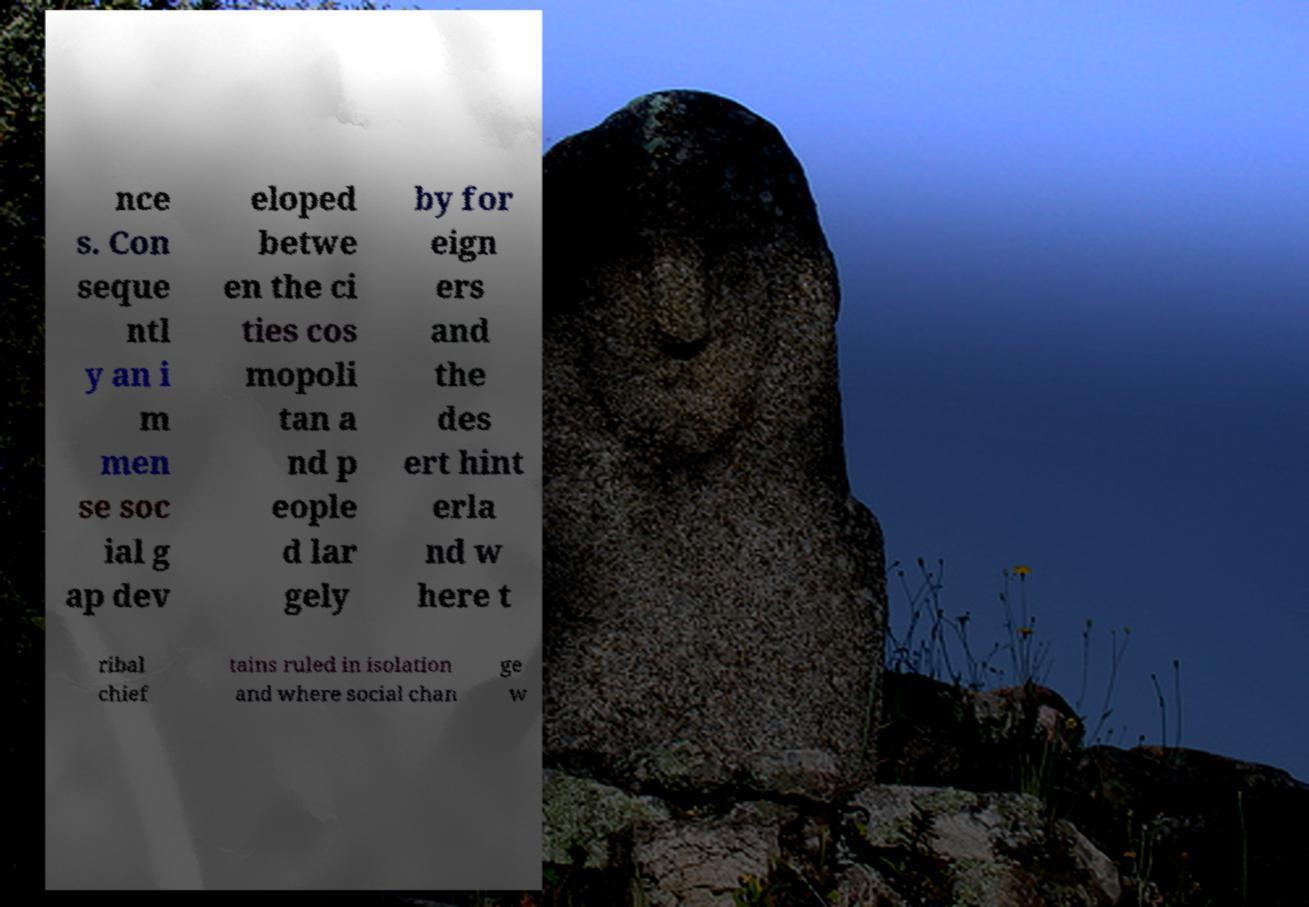I need the written content from this picture converted into text. Can you do that? nce s. Con seque ntl y an i m men se soc ial g ap dev eloped betwe en the ci ties cos mopoli tan a nd p eople d lar gely by for eign ers and the des ert hint erla nd w here t ribal chief tains ruled in isolation and where social chan ge w 